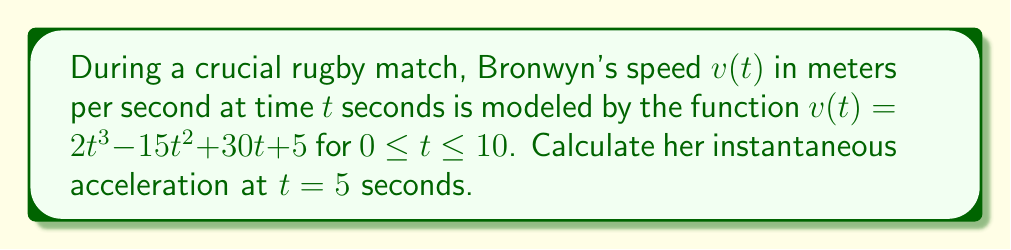Can you solve this math problem? To find Bronwyn's instantaneous acceleration at $t = 5$ seconds, we need to determine the rate of change of her velocity function at that moment. This is equivalent to finding the second derivative of the position function, or the first derivative of the velocity function.

Step 1: Find the first derivative of $v(t)$.
The velocity function is $v(t) = 2t^3 - 15t^2 + 30t + 5$
The acceleration function $a(t)$ is the derivative of $v(t)$:
$$a(t) = v'(t) = \frac{d}{dt}(2t^3 - 15t^2 + 30t + 5)$$
$$a(t) = 6t^2 - 30t + 30$$

Step 2: Evaluate $a(t)$ at $t = 5$.
$$a(5) = 6(5^2) - 30(5) + 30$$
$$a(5) = 6(25) - 150 + 30$$
$$a(5) = 150 - 150 + 30$$
$$a(5) = 30$$

Therefore, Bronwyn's instantaneous acceleration at $t = 5$ seconds is 30 m/s².
Answer: 30 m/s² 